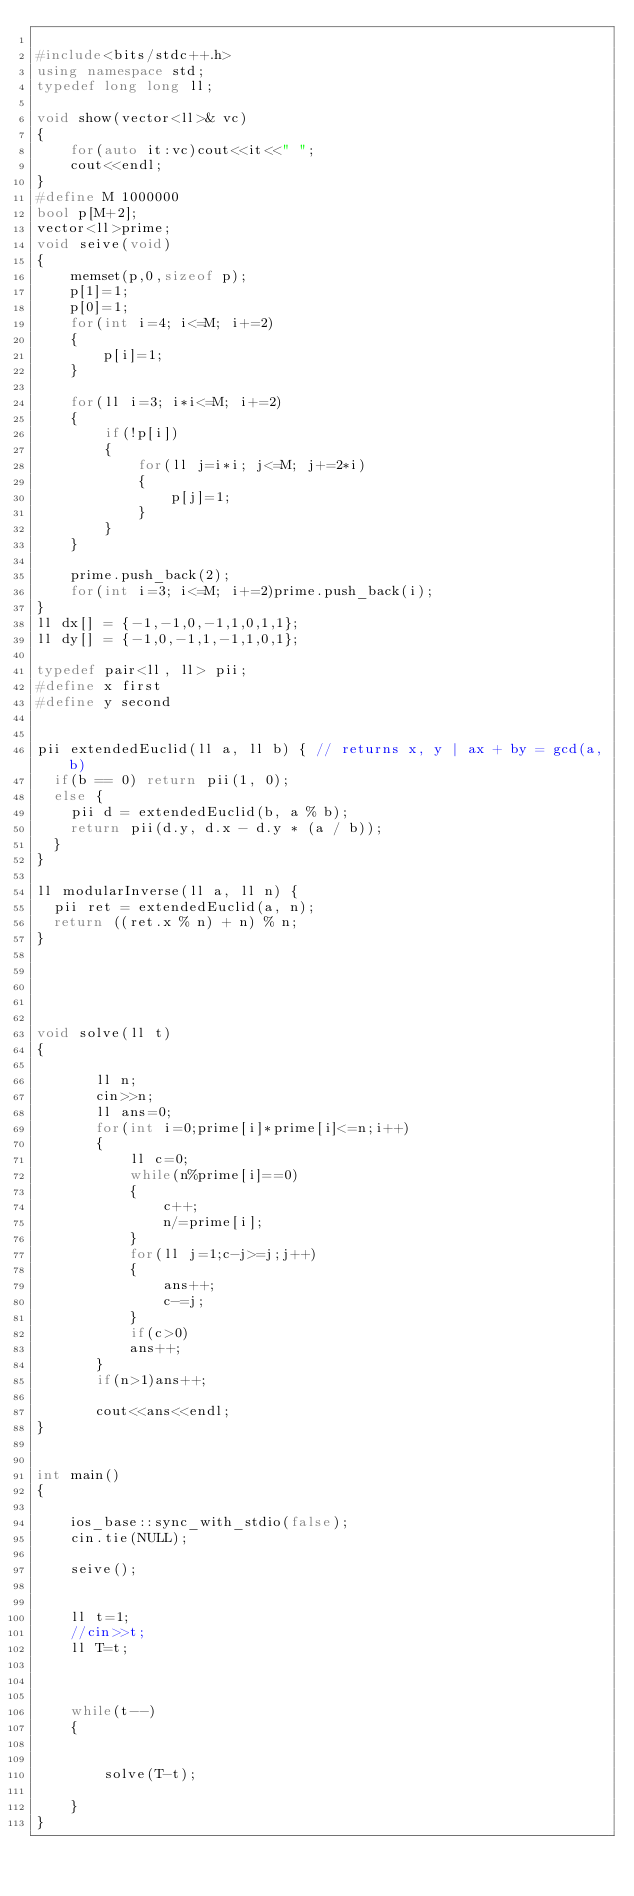Convert code to text. <code><loc_0><loc_0><loc_500><loc_500><_C++_>
#include<bits/stdc++.h>
using namespace std;
typedef long long ll;

void show(vector<ll>& vc)
{
    for(auto it:vc)cout<<it<<" ";
    cout<<endl;
}
#define M 1000000
bool p[M+2];
vector<ll>prime;
void seive(void)
{
    memset(p,0,sizeof p);
    p[1]=1;
    p[0]=1;
    for(int i=4; i<=M; i+=2)
    {
        p[i]=1;
    }

    for(ll i=3; i*i<=M; i+=2)
    {
        if(!p[i])
        {
            for(ll j=i*i; j<=M; j+=2*i)
            {
                p[j]=1;
            }
        }
    }

    prime.push_back(2);
    for(int i=3; i<=M; i+=2)prime.push_back(i);
}
ll dx[] = {-1,-1,0,-1,1,0,1,1};
ll dy[] = {-1,0,-1,1,-1,1,0,1};

typedef pair<ll, ll> pii;
#define x first
#define y second


pii extendedEuclid(ll a, ll b) { // returns x, y | ax + by = gcd(a,b)
  if(b == 0) return pii(1, 0);
  else {
    pii d = extendedEuclid(b, a % b);
    return pii(d.y, d.x - d.y * (a / b));
  }
}

ll modularInverse(ll a, ll n) {
  pii ret = extendedEuclid(a, n);
  return ((ret.x % n) + n) % n;
}





void solve(ll t)
{

       ll n;
       cin>>n;
       ll ans=0;
       for(int i=0;prime[i]*prime[i]<=n;i++)
       {
           ll c=0;
           while(n%prime[i]==0)
           {
               c++;
               n/=prime[i];
           }
           for(ll j=1;c-j>=j;j++)
           {
               ans++;
               c-=j;
           }
           if(c>0)
           ans++;
       }
       if(n>1)ans++;

       cout<<ans<<endl;
}


int main()
{

    ios_base::sync_with_stdio(false);
    cin.tie(NULL);

    seive();


    ll t=1;
    //cin>>t;
    ll T=t;



    while(t--)
    {


        solve(T-t);

    }
}
</code> 